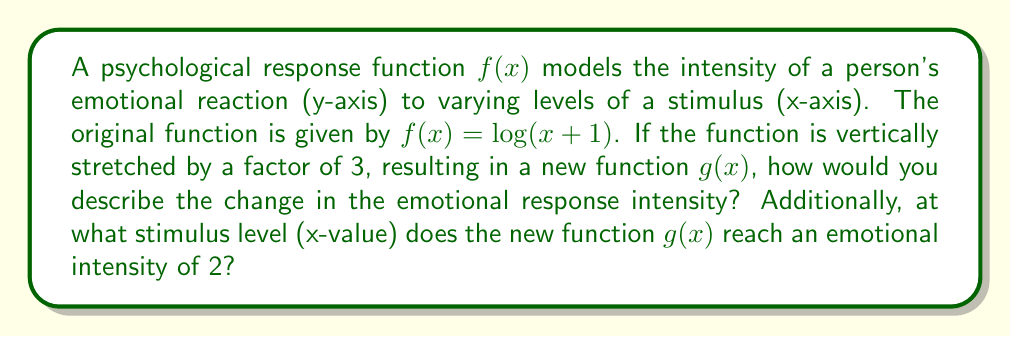Provide a solution to this math problem. To analyze the effect of vertical stretching on the psychological response function, we need to follow these steps:

1) The vertical stretch by a factor of 3 transforms the original function $f(x)$ into $g(x)$ as follows:

   $g(x) = 3f(x) = 3\log(x+1)$

2) This transformation affects the emotional response intensity (y-values) but not the stimulus levels (x-values). Each y-value of the original function is multiplied by 3.

3) Psychologically, this means that for any given stimulus level, the emotional response intensity is now three times stronger than it was in the original function.

4) To find the stimulus level where $g(x)$ reaches an emotional intensity of 2, we set up the equation:

   $g(x) = 2$
   $3\log(x+1) = 2$

5) Solve for x:
   $\log(x+1) = \frac{2}{3}$
   $x + 1 = e^{\frac{2}{3}}$
   $x = e^{\frac{2}{3}} - 1 \approx 0.9477$

Therefore, the new function $g(x)$ reaches an emotional intensity of 2 when the stimulus level is approximately 0.9477.
Answer: The vertical stretch amplifies the emotional response intensity by a factor of 3 for all stimulus levels. The new function $g(x)$ reaches an emotional intensity of 2 at a stimulus level of approximately 0.9477. 